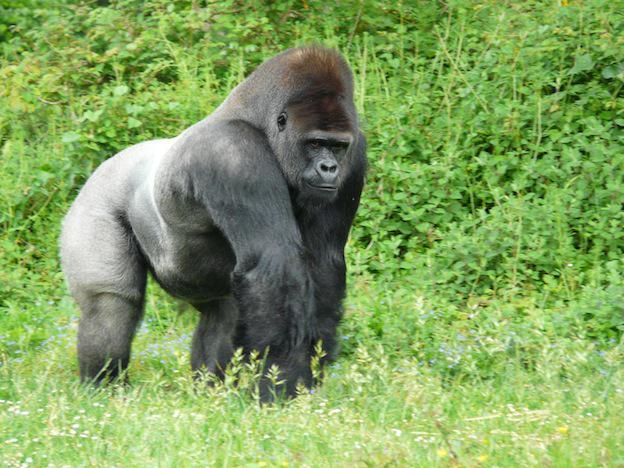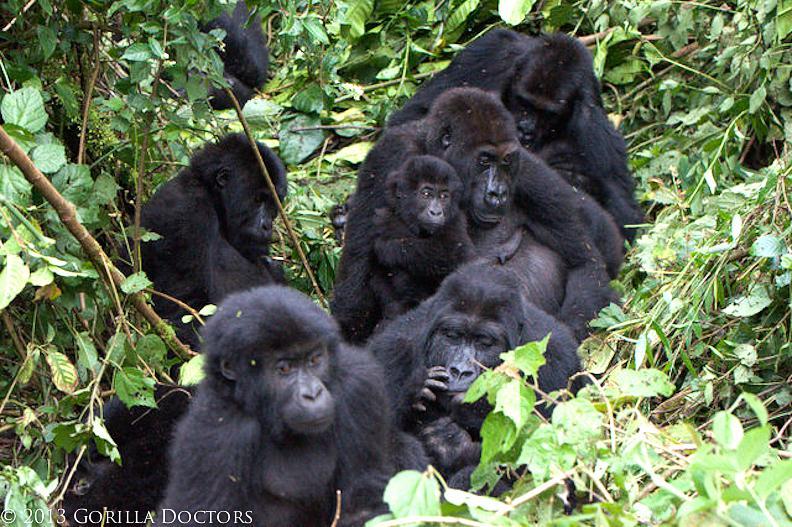The first image is the image on the left, the second image is the image on the right. Considering the images on both sides, is "The left image contains exactly one silver back gorilla." valid? Answer yes or no. Yes. The first image is the image on the left, the second image is the image on the right. Examine the images to the left and right. Is the description "The left image shows a single silverback male gorilla, and the right image shows a group of gorillas of various ages and sizes." accurate? Answer yes or no. Yes. 